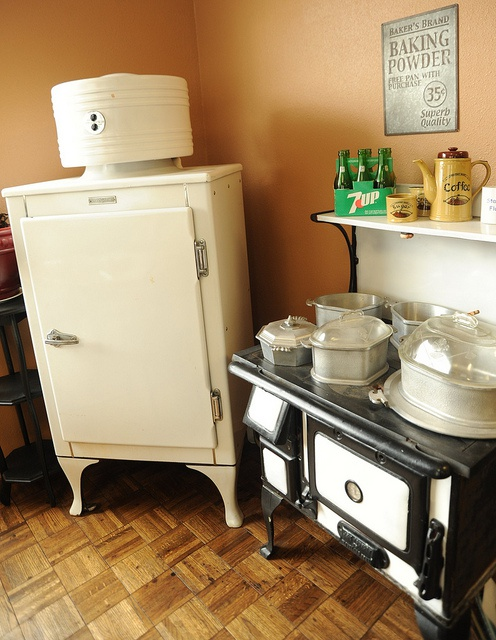Describe the objects in this image and their specific colors. I can see refrigerator in brown, tan, and beige tones, oven in brown, white, black, gray, and darkgray tones, cup in brown, tan, khaki, and olive tones, bottle in brown, black, darkgreen, and green tones, and bottle in brown, black, darkgreen, and green tones in this image. 